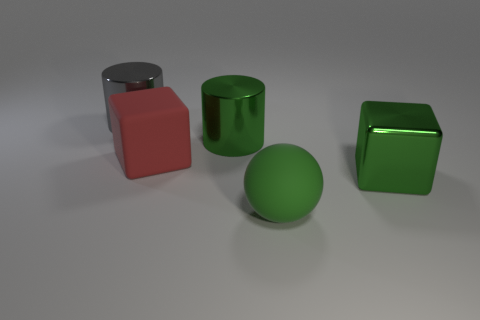Is the large matte ball the same color as the big shiny block?
Your response must be concise. Yes. There is a matte sphere that is the same size as the red matte object; what is its color?
Give a very brief answer. Green. There is a thing that is left of the red matte object; what is it made of?
Your answer should be very brief. Metal. Is the shape of the large green thing that is behind the large red rubber block the same as the metal object left of the green shiny cylinder?
Your response must be concise. Yes. Is the number of large rubber balls to the right of the gray cylinder the same as the number of large red things?
Your answer should be compact. Yes. How many large red things are made of the same material as the big green cylinder?
Your answer should be very brief. 0. What color is the other large cylinder that is the same material as the big green cylinder?
Give a very brief answer. Gray. There is a gray object; does it have the same size as the matte thing right of the big red object?
Offer a very short reply. Yes. There is a red rubber thing; what shape is it?
Ensure brevity in your answer.  Cube. What number of cubes have the same color as the big matte ball?
Offer a terse response. 1. 